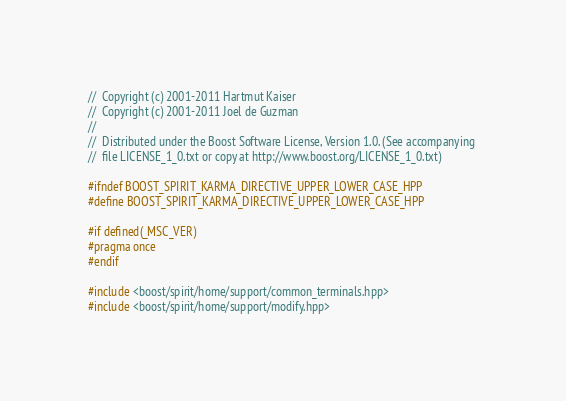Convert code to text. <code><loc_0><loc_0><loc_500><loc_500><_C++_>//  Copyright (c) 2001-2011 Hartmut Kaiser
//  Copyright (c) 2001-2011 Joel de Guzman
// 
//  Distributed under the Boost Software License, Version 1.0. (See accompanying 
//  file LICENSE_1_0.txt or copy at http://www.boost.org/LICENSE_1_0.txt)

#ifndef BOOST_SPIRIT_KARMA_DIRECTIVE_UPPER_LOWER_CASE_HPP
#define BOOST_SPIRIT_KARMA_DIRECTIVE_UPPER_LOWER_CASE_HPP

#if defined(_MSC_VER)
#pragma once
#endif

#include <boost/spirit/home/support/common_terminals.hpp>
#include <boost/spirit/home/support/modify.hpp></code> 